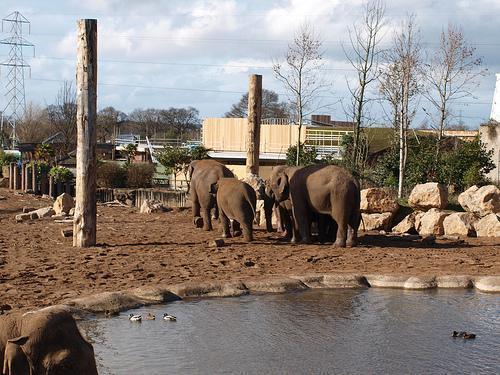How many ducks are visible in this photo?
Give a very brief answer. 6. How many elephants are visible in this photo?
Give a very brief answer. 5. How many tall wood poles are pictured?
Give a very brief answer. 2. 